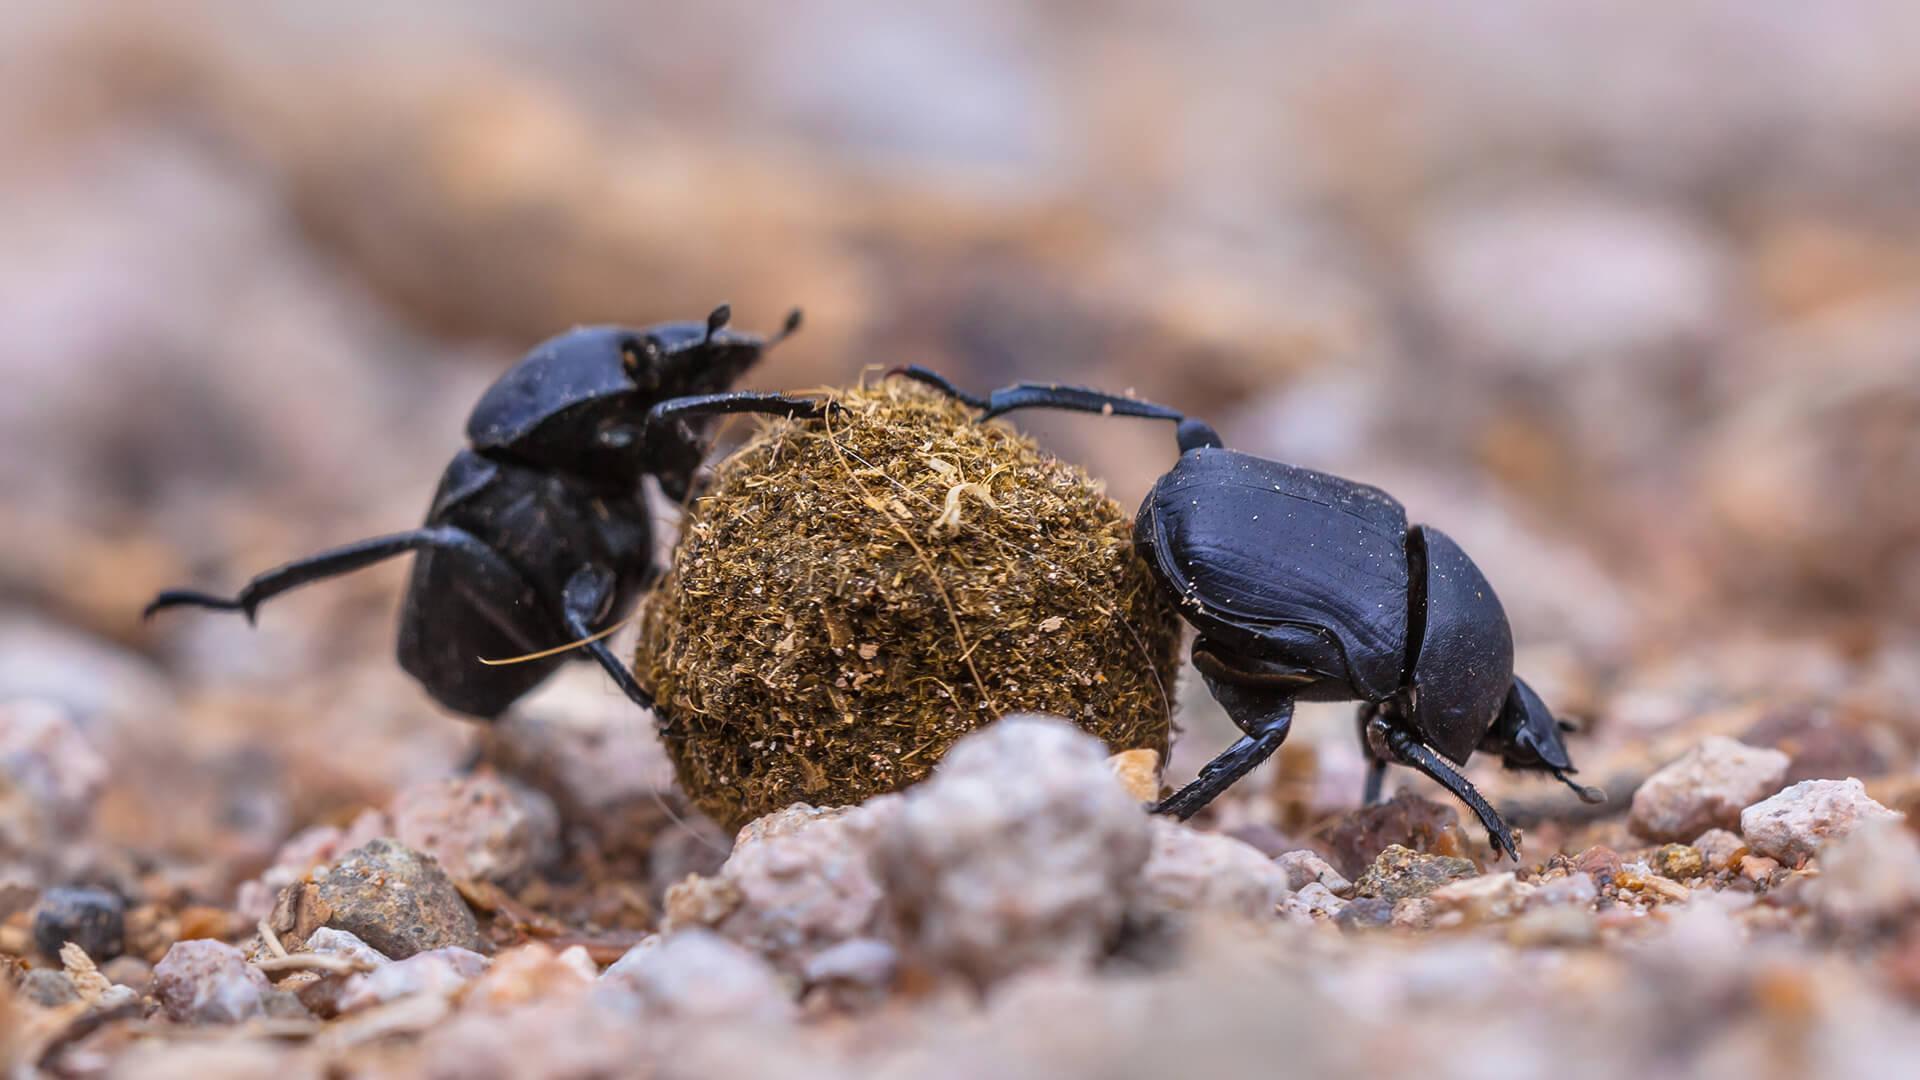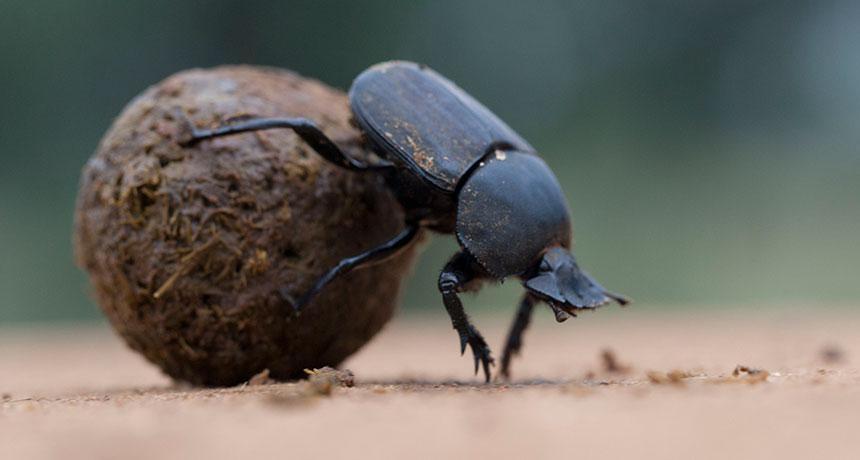The first image is the image on the left, the second image is the image on the right. Analyze the images presented: Is the assertion "There are at least two beetles touching  a dungball." valid? Answer yes or no. Yes. The first image is the image on the left, the second image is the image on the right. Considering the images on both sides, is "At least one beetle crawls on a clod of dirt in each of the images." valid? Answer yes or no. Yes. The first image is the image on the left, the second image is the image on the right. Examine the images to the left and right. Is the description "In one of the image a dung beetle is on top of the dung ball." accurate? Answer yes or no. No. 